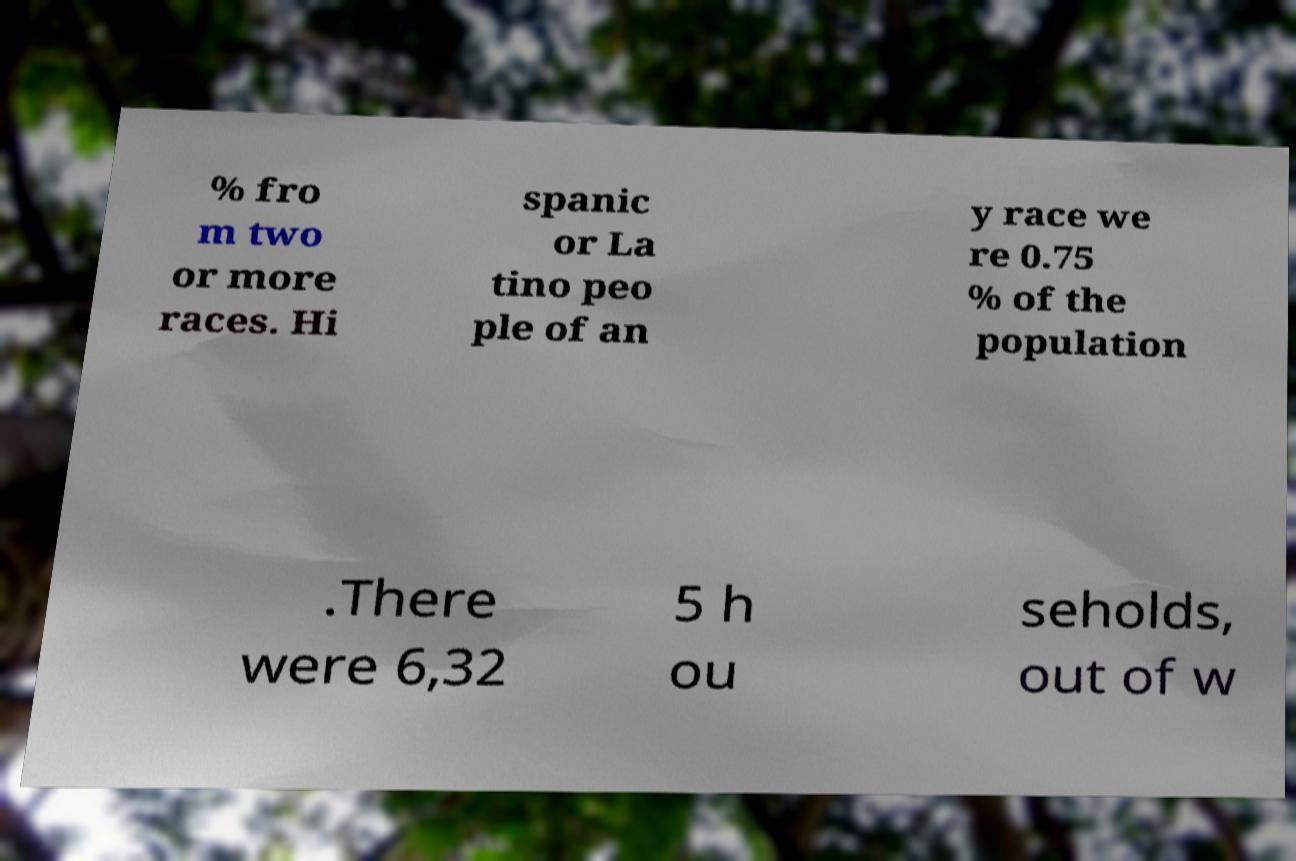Please identify and transcribe the text found in this image. % fro m two or more races. Hi spanic or La tino peo ple of an y race we re 0.75 % of the population .There were 6,32 5 h ou seholds, out of w 